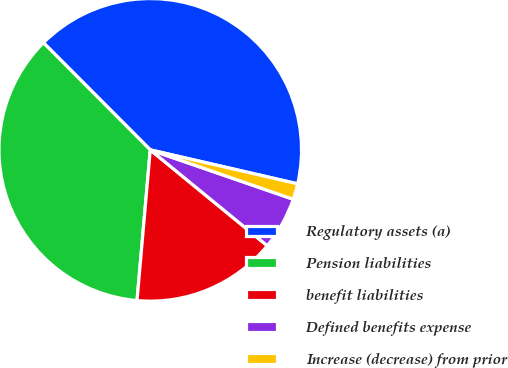Convert chart to OTSL. <chart><loc_0><loc_0><loc_500><loc_500><pie_chart><fcel>Regulatory assets (a)<fcel>Pension liabilities<fcel>benefit liabilities<fcel>Defined benefits expense<fcel>Increase (decrease) from prior<nl><fcel>41.08%<fcel>36.13%<fcel>15.47%<fcel>5.63%<fcel>1.69%<nl></chart> 